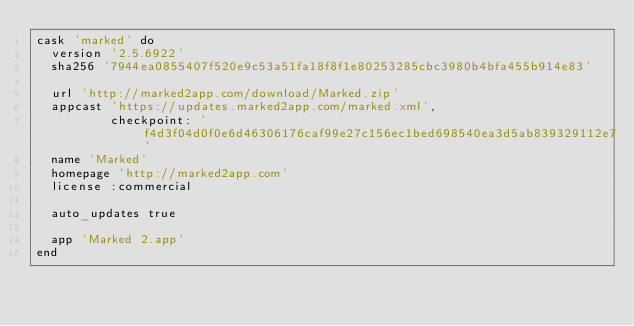Convert code to text. <code><loc_0><loc_0><loc_500><loc_500><_Ruby_>cask 'marked' do
  version '2.5.6922'
  sha256 '7944ea0855407f520e9c53a51fa18f8f1e80253285cbc3980b4bfa455b914e83'

  url 'http://marked2app.com/download/Marked.zip'
  appcast 'https://updates.marked2app.com/marked.xml',
          checkpoint: 'f4d3f04d0f0e6d46306176caf99e27c156ec1bed698540ea3d5ab839329112e7'
  name 'Marked'
  homepage 'http://marked2app.com'
  license :commercial

  auto_updates true

  app 'Marked 2.app'
end
</code> 